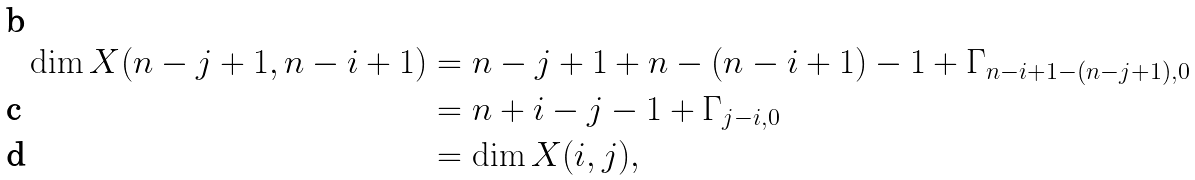<formula> <loc_0><loc_0><loc_500><loc_500>\dim X ( n - j + 1 , n - i + 1 ) & = n - j + 1 + n - ( n - i + 1 ) - 1 + \Gamma _ { n - i + 1 - ( n - j + 1 ) , 0 } \\ & = n + i - j - 1 + \Gamma _ { j - i , 0 } \\ & = \dim X ( i , j ) ,</formula> 